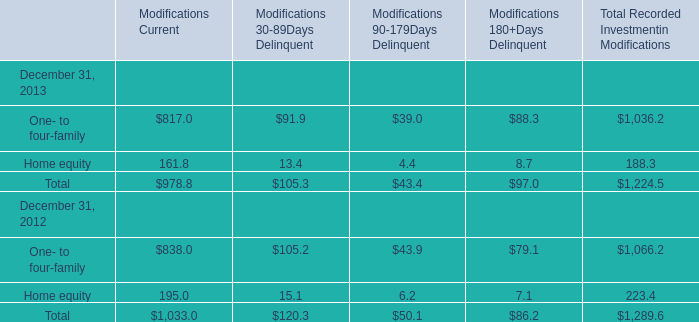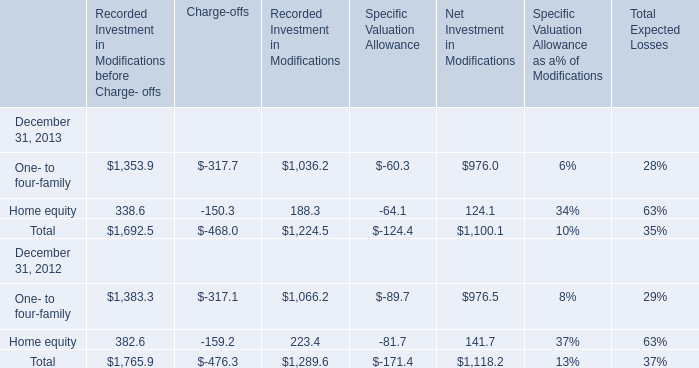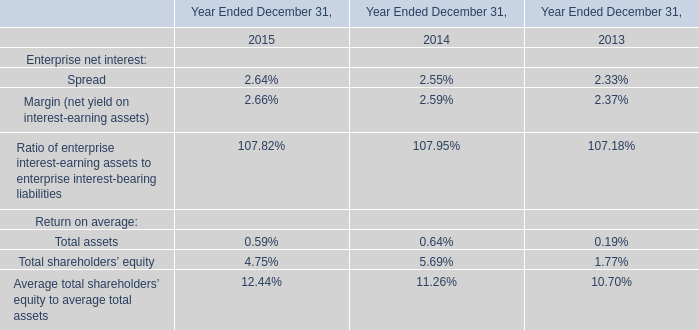In the year with lowest amount of Total Recorded Investment in Modifications before Charge- offs, what's the increasing rate of Recorded Investment in Modifications before Charge- offs of Home equity? 
Computations: ((338.6 - 382.6) / 382.6)
Answer: -0.115. 